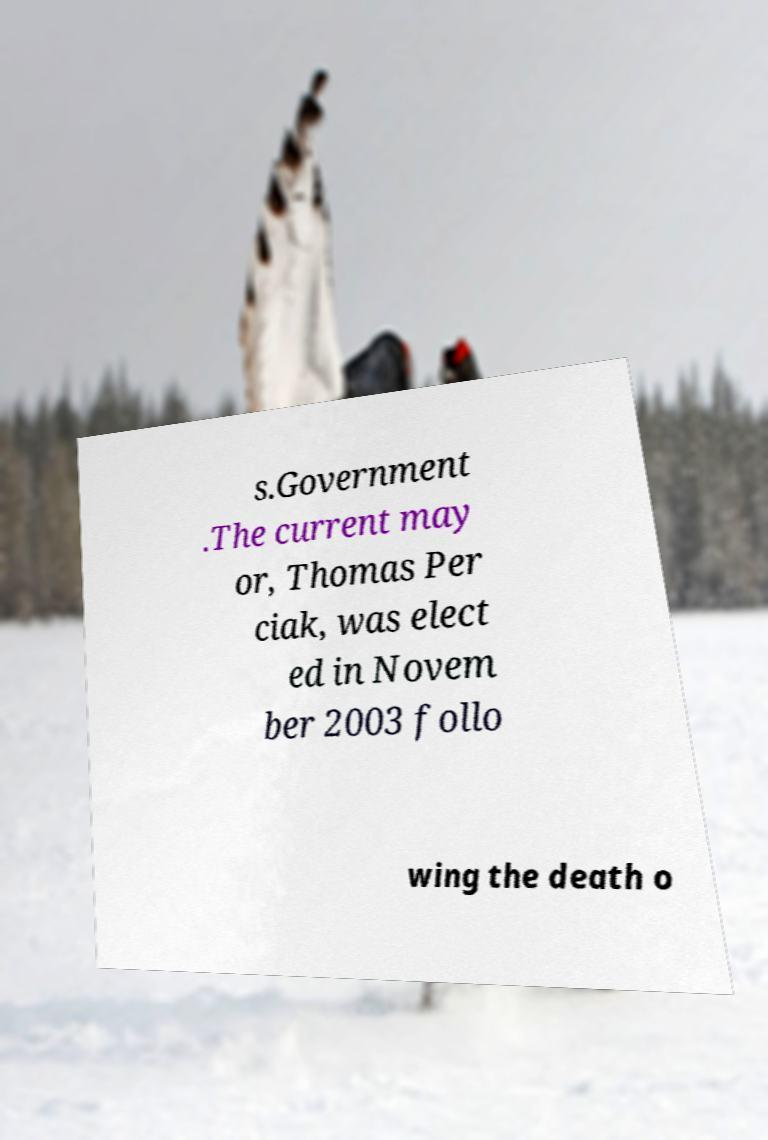What messages or text are displayed in this image? I need them in a readable, typed format. s.Government .The current may or, Thomas Per ciak, was elect ed in Novem ber 2003 follo wing the death o 